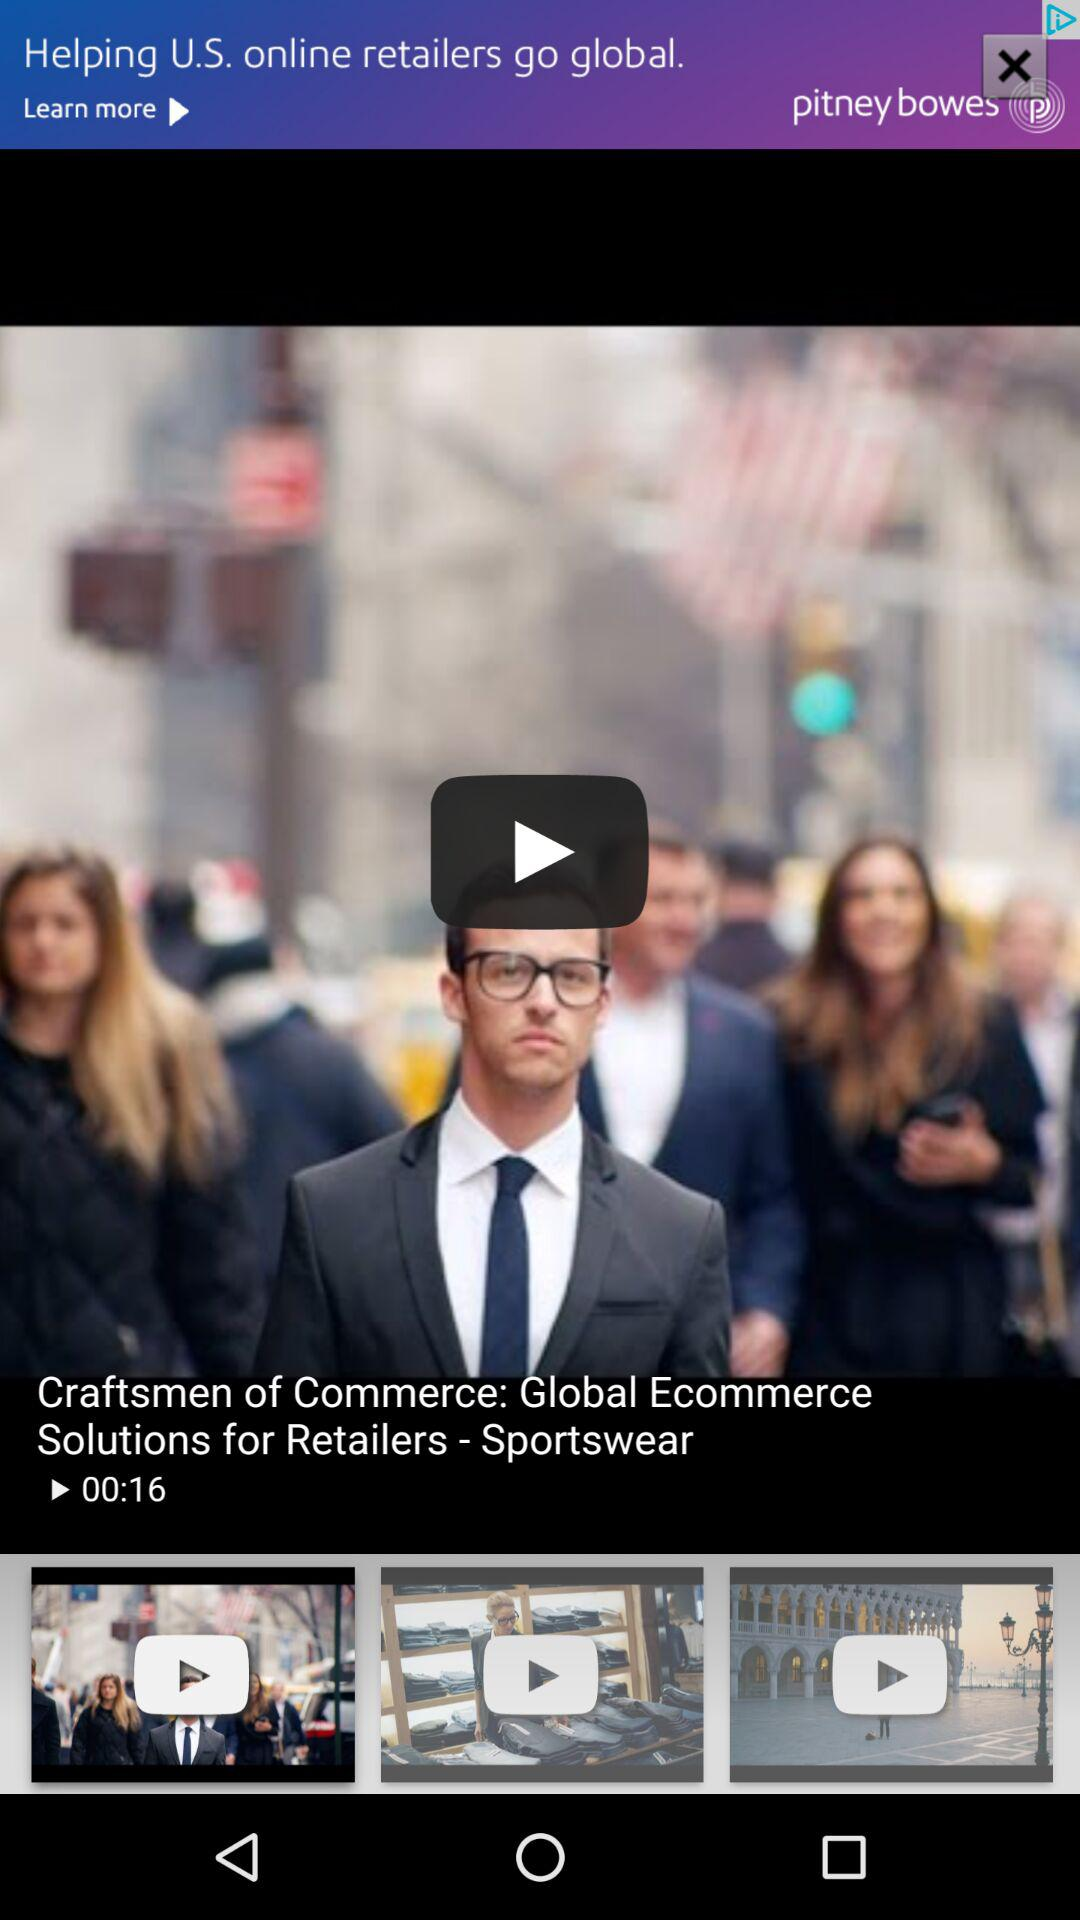What is the video's name? The video's name is "Craftsmen of Commerce: Global Ecommerce Solutions for Retailers - Sportswear". 